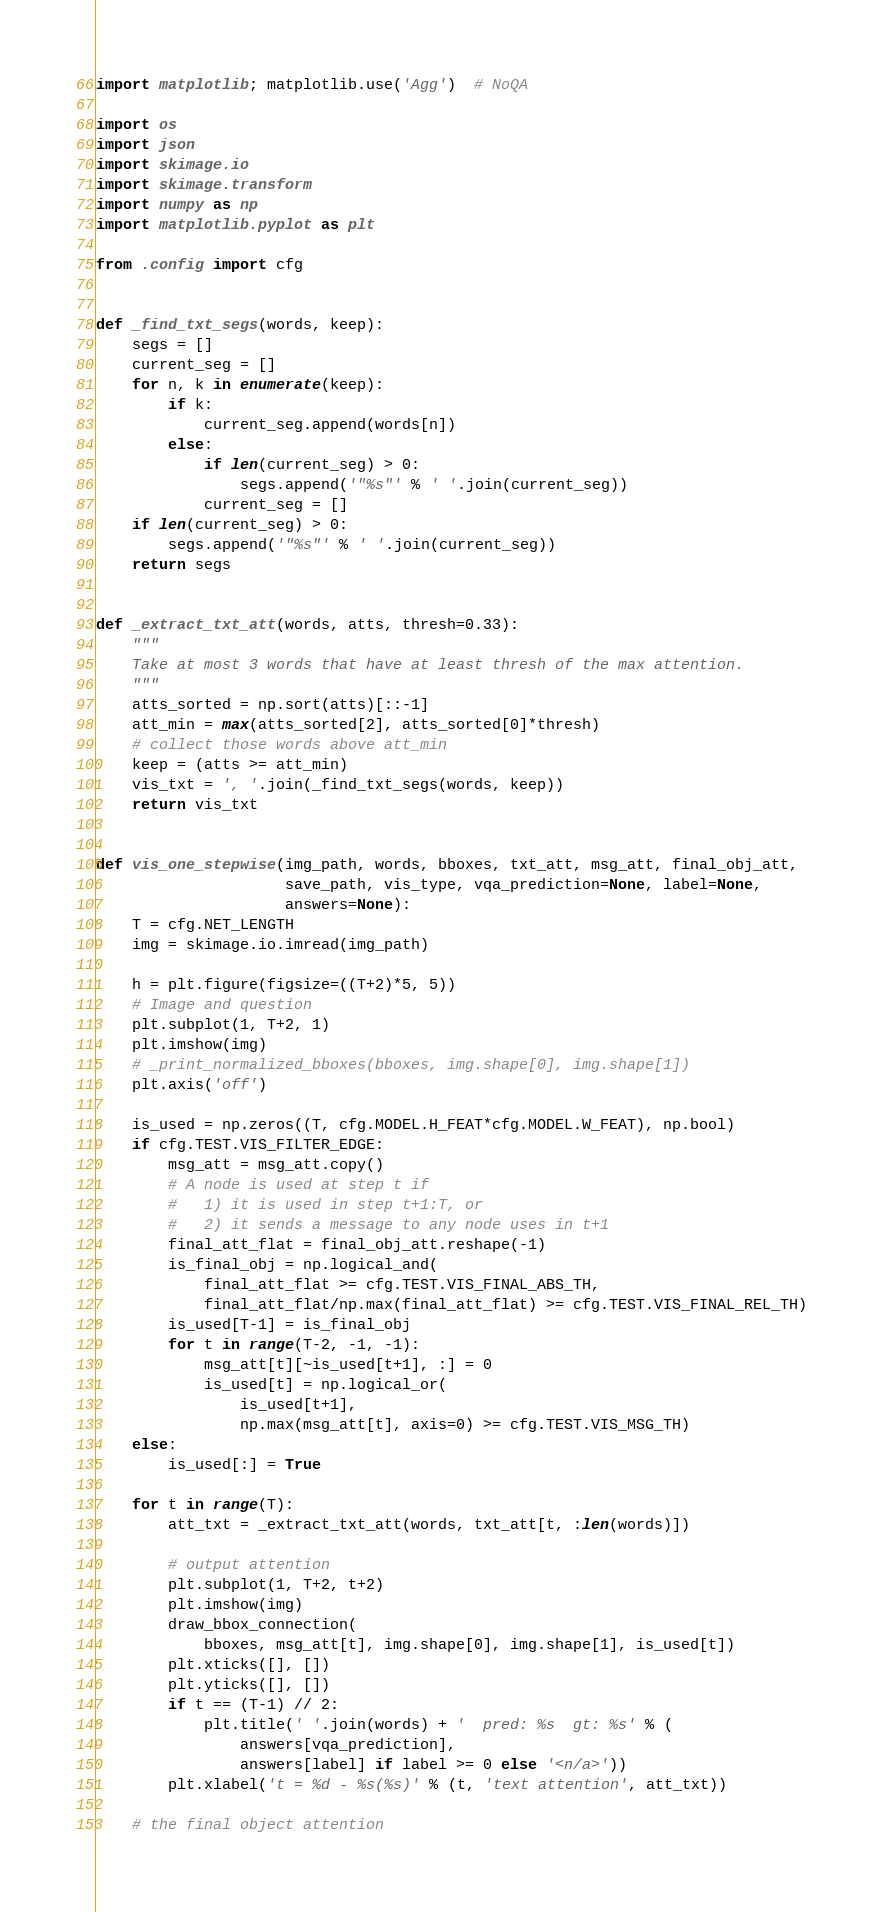Convert code to text. <code><loc_0><loc_0><loc_500><loc_500><_Python_>import matplotlib; matplotlib.use('Agg')  # NoQA

import os
import json
import skimage.io
import skimage.transform
import numpy as np
import matplotlib.pyplot as plt

from .config import cfg


def _find_txt_segs(words, keep):
    segs = []
    current_seg = []
    for n, k in enumerate(keep):
        if k:
            current_seg.append(words[n])
        else:
            if len(current_seg) > 0:
                segs.append('"%s"' % ' '.join(current_seg))
            current_seg = []
    if len(current_seg) > 0:
        segs.append('"%s"' % ' '.join(current_seg))
    return segs


def _extract_txt_att(words, atts, thresh=0.33):
    """
    Take at most 3 words that have at least thresh of the max attention.
    """
    atts_sorted = np.sort(atts)[::-1]
    att_min = max(atts_sorted[2], atts_sorted[0]*thresh)
    # collect those words above att_min
    keep = (atts >= att_min)
    vis_txt = ', '.join(_find_txt_segs(words, keep))
    return vis_txt


def vis_one_stepwise(img_path, words, bboxes, txt_att, msg_att, final_obj_att,
                     save_path, vis_type, vqa_prediction=None, label=None,
                     answers=None):
    T = cfg.NET_LENGTH
    img = skimage.io.imread(img_path)

    h = plt.figure(figsize=((T+2)*5, 5))
    # Image and question
    plt.subplot(1, T+2, 1)
    plt.imshow(img)
    # _print_normalized_bboxes(bboxes, img.shape[0], img.shape[1])
    plt.axis('off')

    is_used = np.zeros((T, cfg.MODEL.H_FEAT*cfg.MODEL.W_FEAT), np.bool)
    if cfg.TEST.VIS_FILTER_EDGE:
        msg_att = msg_att.copy()
        # A node is used at step t if
        #   1) it is used in step t+1:T, or
        #   2) it sends a message to any node uses in t+1
        final_att_flat = final_obj_att.reshape(-1)
        is_final_obj = np.logical_and(
            final_att_flat >= cfg.TEST.VIS_FINAL_ABS_TH,
            final_att_flat/np.max(final_att_flat) >= cfg.TEST.VIS_FINAL_REL_TH)
        is_used[T-1] = is_final_obj
        for t in range(T-2, -1, -1):
            msg_att[t][~is_used[t+1], :] = 0
            is_used[t] = np.logical_or(
                is_used[t+1],
                np.max(msg_att[t], axis=0) >= cfg.TEST.VIS_MSG_TH)
    else:
        is_used[:] = True

    for t in range(T):
        att_txt = _extract_txt_att(words, txt_att[t, :len(words)])

        # output attention
        plt.subplot(1, T+2, t+2)
        plt.imshow(img)
        draw_bbox_connection(
            bboxes, msg_att[t], img.shape[0], img.shape[1], is_used[t])
        plt.xticks([], [])
        plt.yticks([], [])
        if t == (T-1) // 2:
            plt.title(' '.join(words) + '  pred: %s  gt: %s' % (
                answers[vqa_prediction],
                answers[label] if label >= 0 else '<n/a>'))
        plt.xlabel('t = %d - %s(%s)' % (t, 'text attention', att_txt))

    # the final object attention</code> 